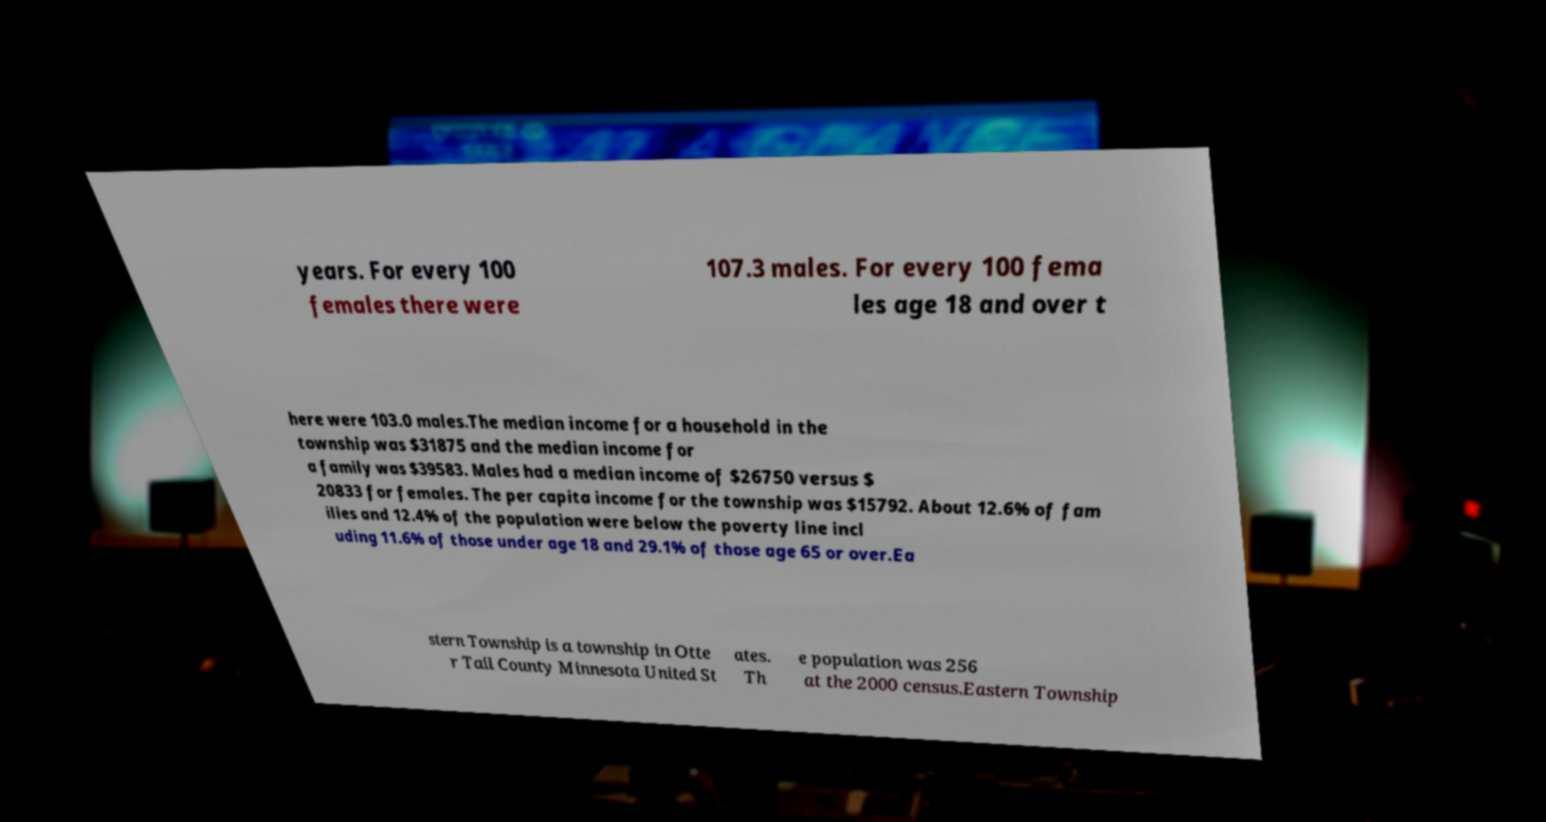Could you extract and type out the text from this image? years. For every 100 females there were 107.3 males. For every 100 fema les age 18 and over t here were 103.0 males.The median income for a household in the township was $31875 and the median income for a family was $39583. Males had a median income of $26750 versus $ 20833 for females. The per capita income for the township was $15792. About 12.6% of fam ilies and 12.4% of the population were below the poverty line incl uding 11.6% of those under age 18 and 29.1% of those age 65 or over.Ea stern Township is a township in Otte r Tail County Minnesota United St ates. Th e population was 256 at the 2000 census.Eastern Township 